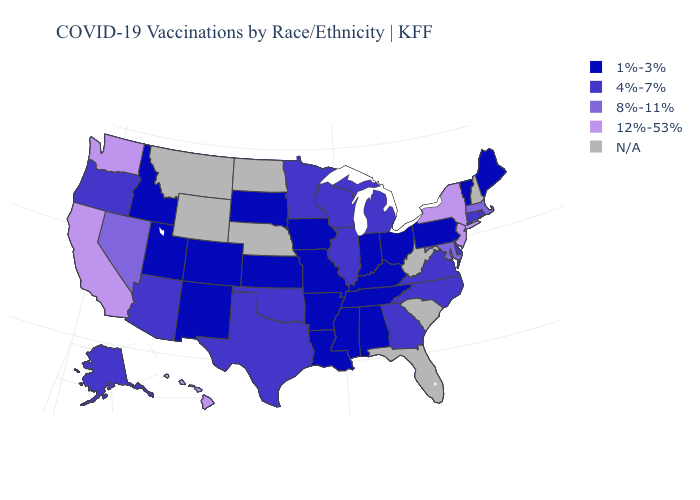Name the states that have a value in the range 4%-7%?
Give a very brief answer. Alaska, Arizona, Connecticut, Delaware, Georgia, Illinois, Michigan, Minnesota, North Carolina, Oklahoma, Oregon, Rhode Island, Texas, Virginia, Wisconsin. Name the states that have a value in the range 8%-11%?
Short answer required. Maryland, Massachusetts, Nevada. Does Maine have the lowest value in the Northeast?
Write a very short answer. Yes. What is the highest value in the Northeast ?
Write a very short answer. 12%-53%. What is the lowest value in the West?
Keep it brief. 1%-3%. Name the states that have a value in the range 1%-3%?
Give a very brief answer. Alabama, Arkansas, Colorado, Idaho, Indiana, Iowa, Kansas, Kentucky, Louisiana, Maine, Mississippi, Missouri, New Mexico, Ohio, Pennsylvania, South Dakota, Tennessee, Utah, Vermont. What is the value of Alabama?
Answer briefly. 1%-3%. Which states have the lowest value in the MidWest?
Quick response, please. Indiana, Iowa, Kansas, Missouri, Ohio, South Dakota. Name the states that have a value in the range 12%-53%?
Concise answer only. California, Hawaii, New Jersey, New York, Washington. Does the first symbol in the legend represent the smallest category?
Short answer required. Yes. What is the lowest value in the USA?
Concise answer only. 1%-3%. Among the states that border Tennessee , does North Carolina have the lowest value?
Be succinct. No. Among the states that border Connecticut , does New York have the highest value?
Give a very brief answer. Yes. 